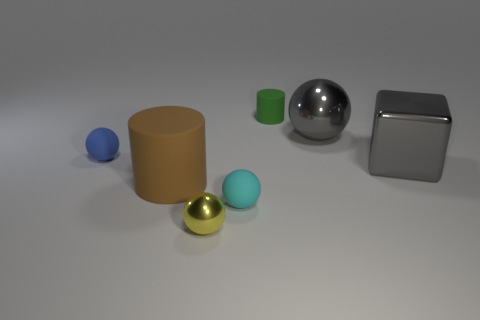Subtract 1 balls. How many balls are left? 3 Add 1 small yellow spheres. How many objects exist? 8 Subtract all cubes. How many objects are left? 6 Subtract all brown cylinders. Subtract all tiny balls. How many objects are left? 3 Add 7 large objects. How many large objects are left? 10 Add 1 purple cubes. How many purple cubes exist? 1 Subtract 1 gray balls. How many objects are left? 6 